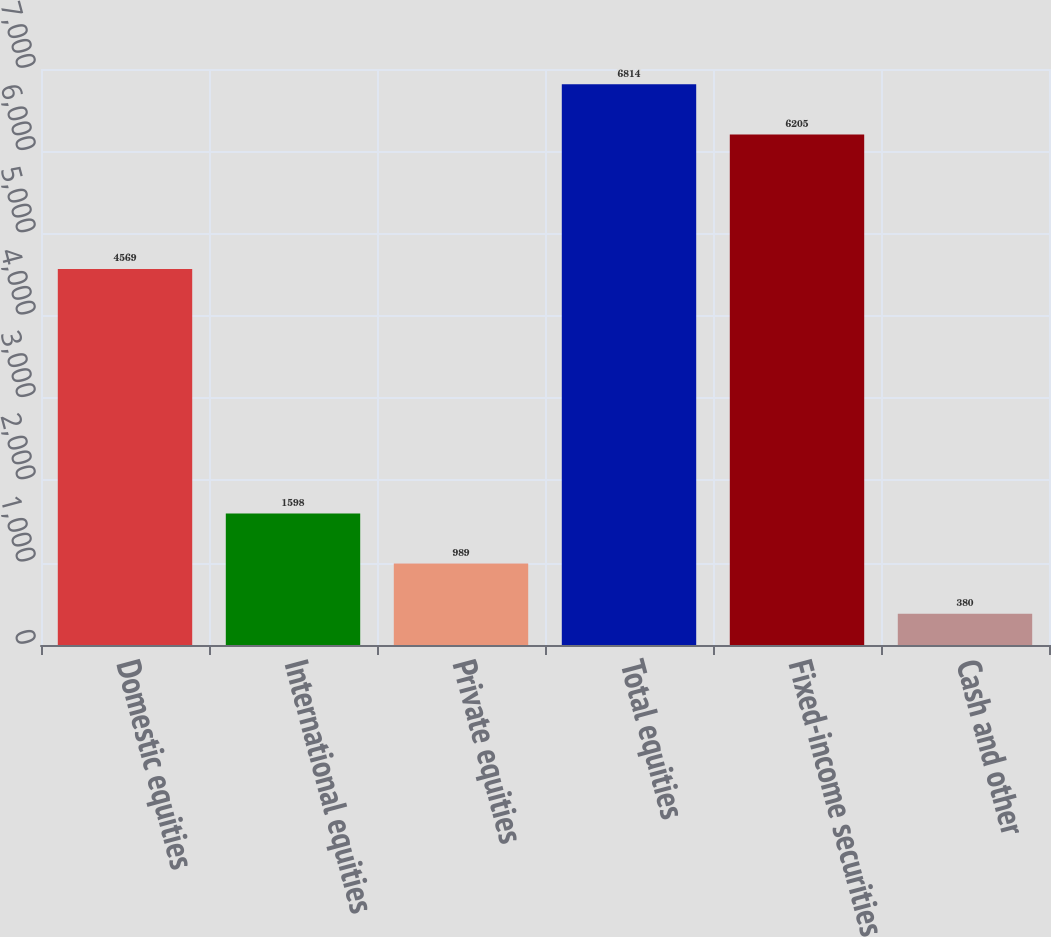<chart> <loc_0><loc_0><loc_500><loc_500><bar_chart><fcel>Domestic equities<fcel>International equities<fcel>Private equities<fcel>Total equities<fcel>Fixed-income securities<fcel>Cash and other<nl><fcel>4569<fcel>1598<fcel>989<fcel>6814<fcel>6205<fcel>380<nl></chart> 